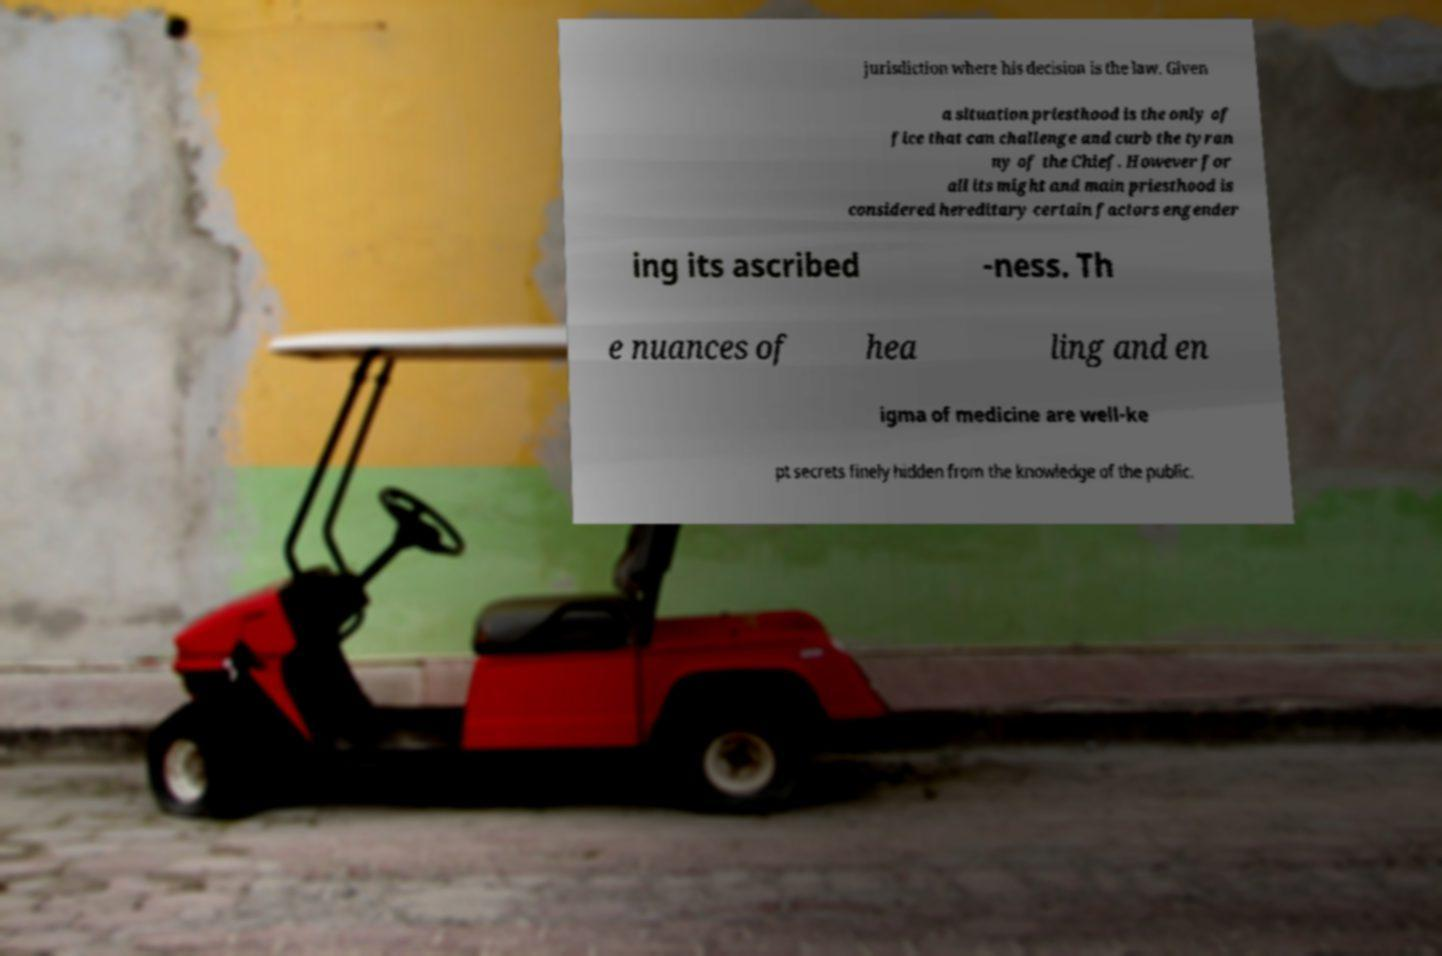There's text embedded in this image that I need extracted. Can you transcribe it verbatim? jurisdiction where his decision is the law. Given a situation priesthood is the only of fice that can challenge and curb the tyran ny of the Chief. However for all its might and main priesthood is considered hereditary certain factors engender ing its ascribed -ness. Th e nuances of hea ling and en igma of medicine are well-ke pt secrets finely hidden from the knowledge of the public. 